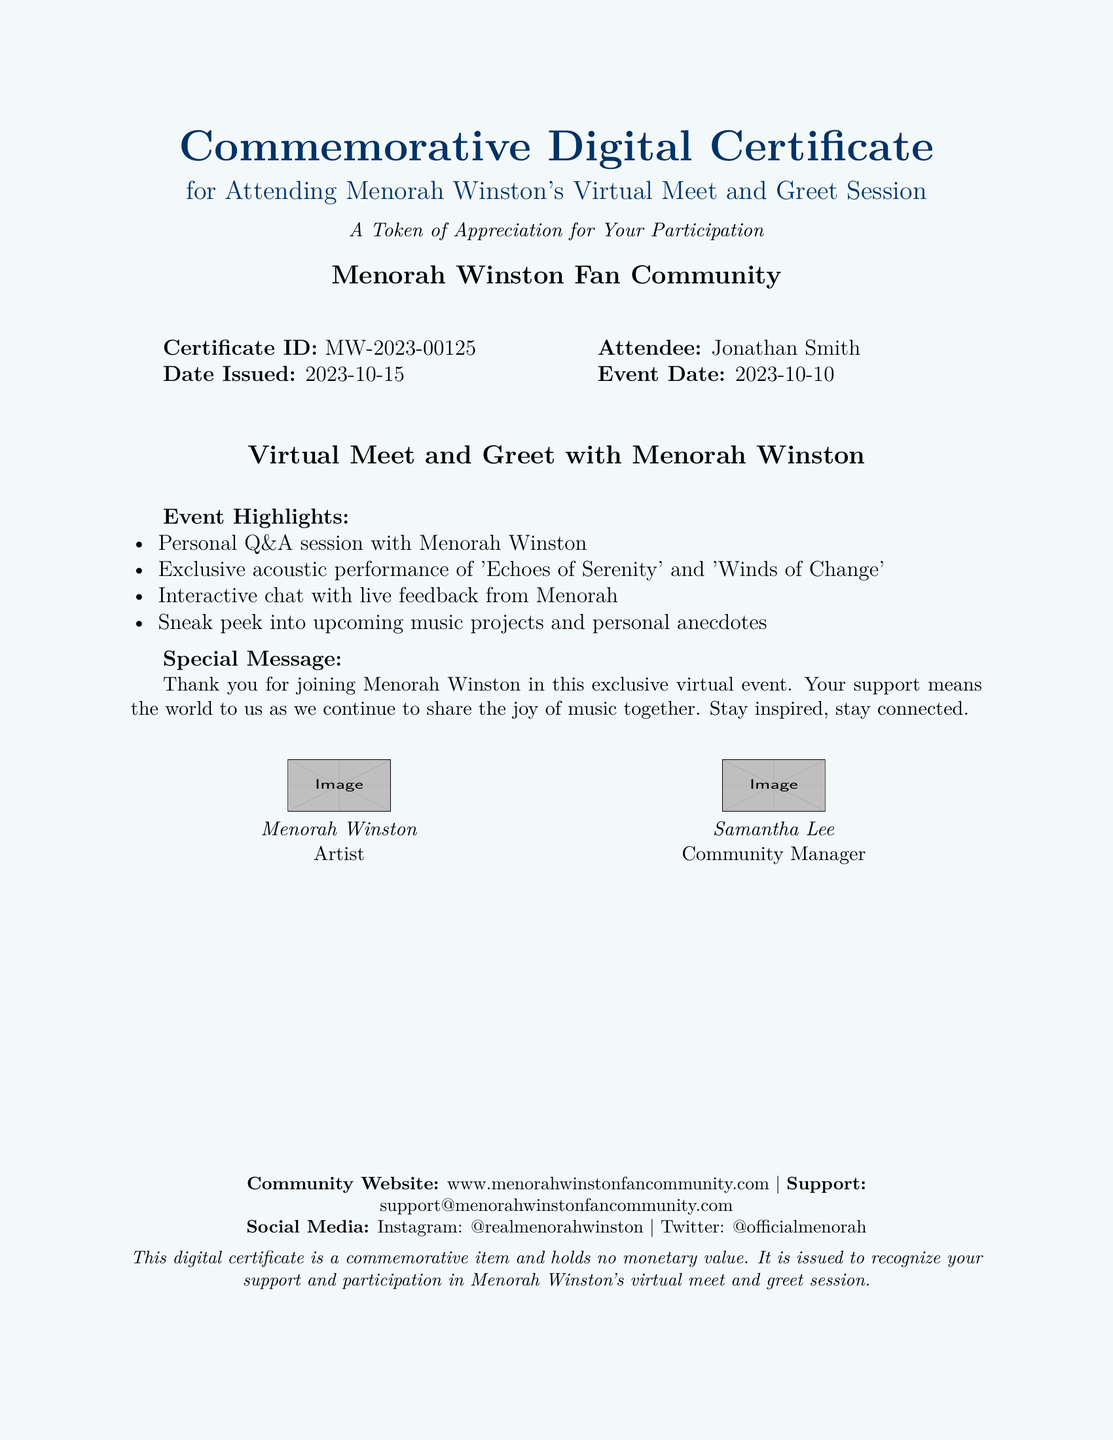What is the Certificate ID? The Certificate ID is specified in the document as a unique identifier for the certificate.
Answer: MW-2023-00125 Who is the attendee? The document mentions the name of the person who attended the event.
Answer: Jonathan Smith When was the event held? The event date is given in the document, detailing when the virtual meet and greet took place.
Answer: 2023-10-10 What were the highlights of the event? The event highlights are listed in the document, summarizing key activities that took place during the meet and greet.
Answer: Personal Q&A session, Exclusive acoustic performance, Interactive chat, Sneak peek into upcoming projects Who issued the certificate? The document specifies the community responsible for issuing the certificate, indicating their identity.
Answer: Menorah Winston Fan Community What is the date issued? The document provides the specific date on which the certificate was issued to the attendee.
Answer: 2023-10-15 What is the purpose of this digital certificate? The document explicitly states the intention behind this certificate in a descriptive manner.
Answer: A Token of Appreciation for Your Participation What is the website for the community? The document includes the URL for the community's website, allowing for further exploration.
Answer: www.menorahwinstonfancommunity.com 